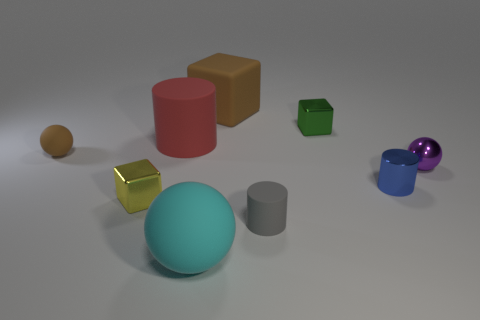There is a blue object that is the same shape as the large red rubber thing; what material is it?
Your answer should be very brief. Metal. What color is the cube that is in front of the small metallic block to the right of the large cyan matte ball?
Offer a terse response. Yellow. How many metallic things are either yellow blocks or large red cylinders?
Give a very brief answer. 1. Does the small purple thing have the same material as the small gray object?
Offer a very short reply. No. There is a ball that is to the right of the brown object to the right of the cyan rubber ball; what is it made of?
Your response must be concise. Metal. What number of tiny objects are blue spheres or brown matte blocks?
Provide a short and direct response. 0. What is the size of the yellow thing?
Provide a short and direct response. Small. Is the number of large matte balls on the left side of the blue shiny thing greater than the number of blue metal balls?
Give a very brief answer. Yes. Are there an equal number of brown balls left of the tiny brown object and large rubber cylinders that are to the left of the large brown thing?
Your response must be concise. No. There is a large rubber object that is behind the yellow metallic block and in front of the brown rubber cube; what is its color?
Offer a terse response. Red. 